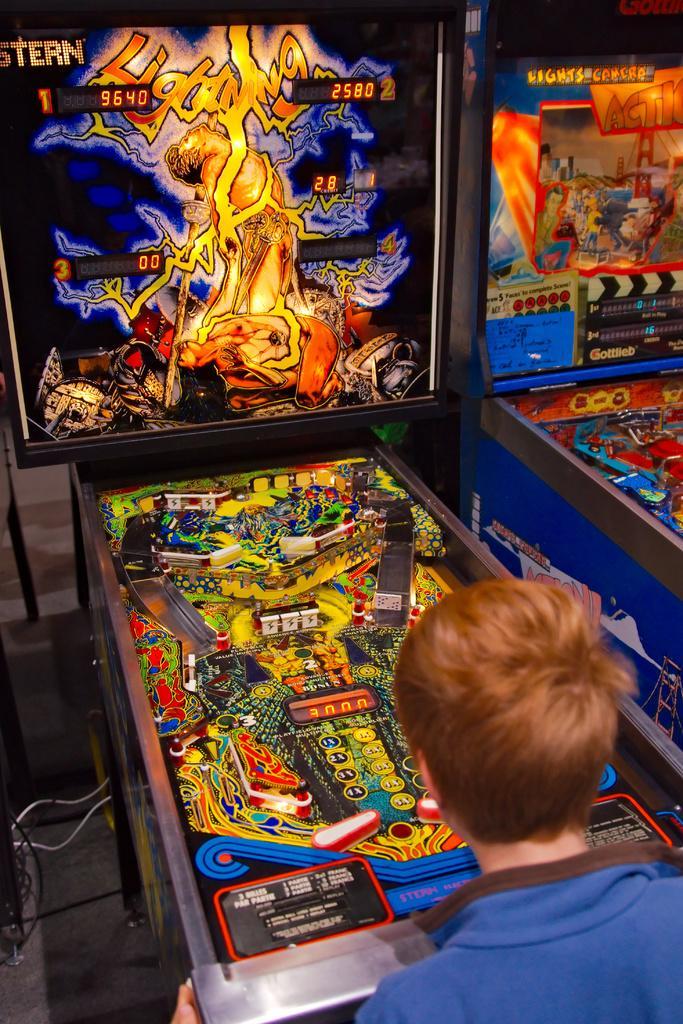Can you describe this image briefly? In this image there is a boy standing and playing game in front of that there is a screen with game. 